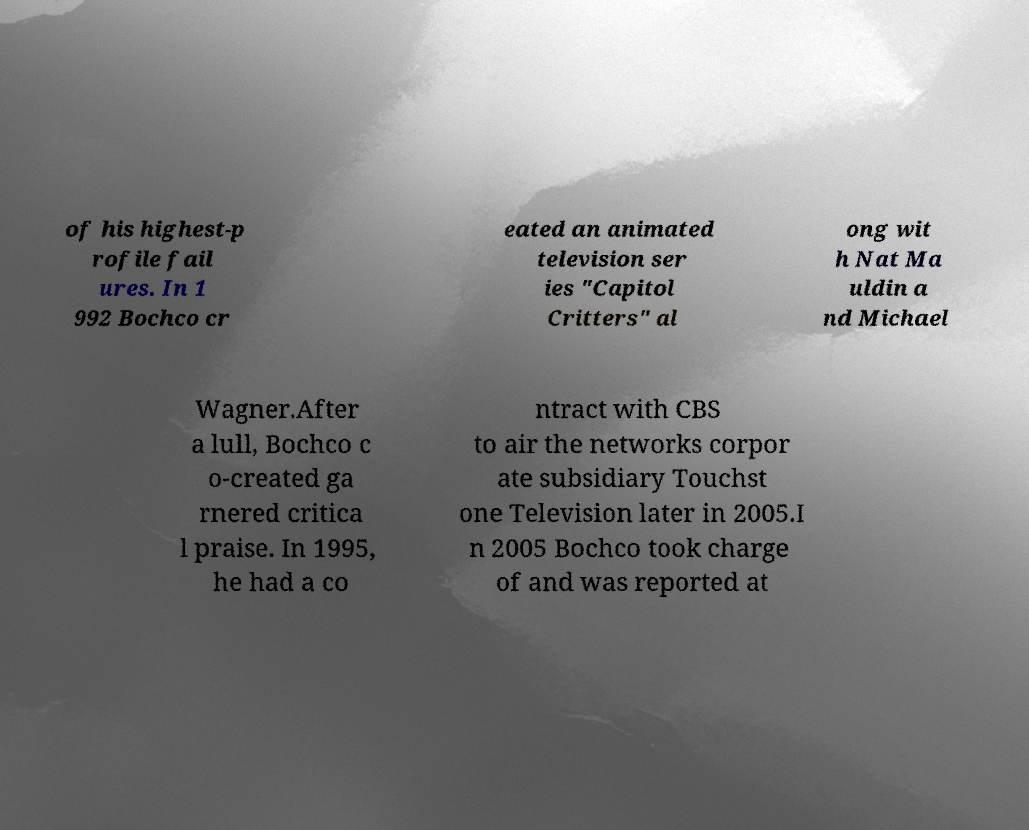Can you accurately transcribe the text from the provided image for me? of his highest-p rofile fail ures. In 1 992 Bochco cr eated an animated television ser ies "Capitol Critters" al ong wit h Nat Ma uldin a nd Michael Wagner.After a lull, Bochco c o-created ga rnered critica l praise. In 1995, he had a co ntract with CBS to air the networks corpor ate subsidiary Touchst one Television later in 2005.I n 2005 Bochco took charge of and was reported at 